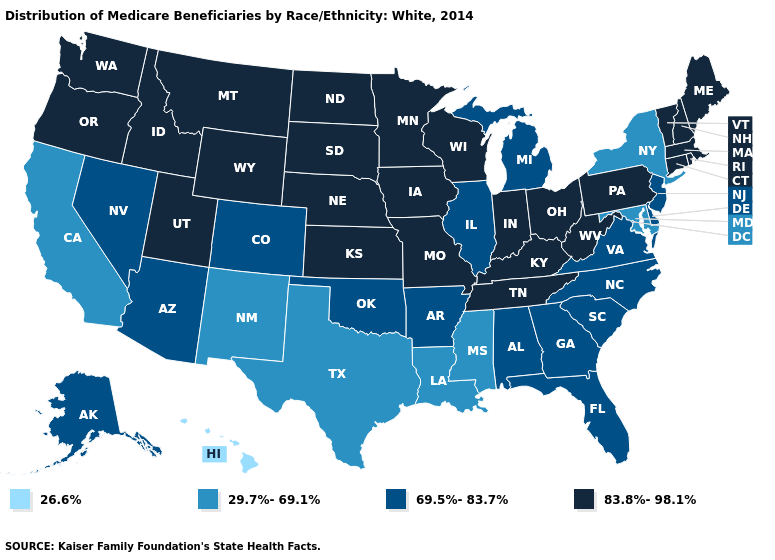Name the states that have a value in the range 69.5%-83.7%?
Quick response, please. Alabama, Alaska, Arizona, Arkansas, Colorado, Delaware, Florida, Georgia, Illinois, Michigan, Nevada, New Jersey, North Carolina, Oklahoma, South Carolina, Virginia. What is the lowest value in the USA?
Keep it brief. 26.6%. Name the states that have a value in the range 26.6%?
Short answer required. Hawaii. Among the states that border Rhode Island , which have the highest value?
Keep it brief. Connecticut, Massachusetts. What is the highest value in states that border Georgia?
Write a very short answer. 83.8%-98.1%. Does Idaho have the highest value in the USA?
Answer briefly. Yes. Does Idaho have the same value as Delaware?
Concise answer only. No. Among the states that border New Jersey , which have the lowest value?
Give a very brief answer. New York. Name the states that have a value in the range 69.5%-83.7%?
Keep it brief. Alabama, Alaska, Arizona, Arkansas, Colorado, Delaware, Florida, Georgia, Illinois, Michigan, Nevada, New Jersey, North Carolina, Oklahoma, South Carolina, Virginia. Name the states that have a value in the range 29.7%-69.1%?
Short answer required. California, Louisiana, Maryland, Mississippi, New Mexico, New York, Texas. Does Michigan have the highest value in the MidWest?
Write a very short answer. No. What is the highest value in the USA?
Write a very short answer. 83.8%-98.1%. Among the states that border North Dakota , which have the lowest value?
Keep it brief. Minnesota, Montana, South Dakota. What is the lowest value in the USA?
Quick response, please. 26.6%. 